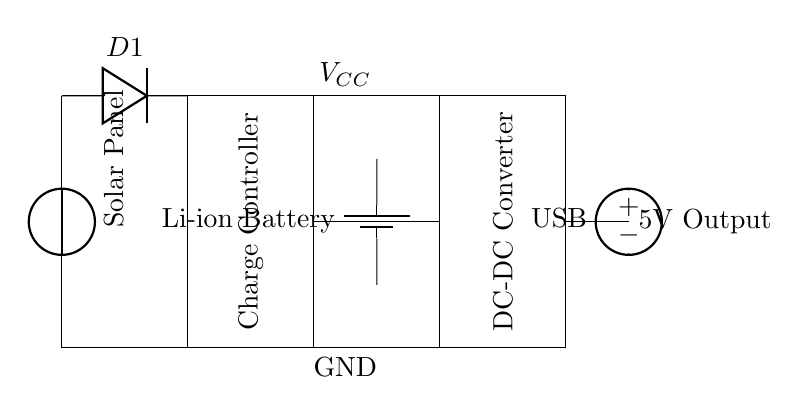What is the component labeled as D1? D1 is a diode, which allows current to flow in one direction only, protecting the circuit from reverse polarity from the solar panel.
Answer: Diode What is the purpose of the charge controller? The charge controller regulates the voltage and current coming from the solar panel to ensure proper charging of the battery, preventing overcharging.
Answer: Regulate charging How many outputs does the DC-DC converter provide? The circuit shows one output from the DC-DC converter, which is connected to the USB output.
Answer: One What is the voltage output at the USB? The USB output voltage is labeled as 5V, which is a standard voltage for USB devices, indicating the power available for charging.
Answer: 5V What type of battery is used in this circuit? The battery used in this circuit is a lithium-ion battery, which is commonly used due to its high energy density and efficiency.
Answer: Li-ion Battery What connection is made from the solar panel to the charge controller? The solar panel connects directly to the diode, and then to the input of the charge controller, ensuring the current is directed properly.
Answer: Diode to Charge Controller What role does the DC-DC converter play in the circuit? The DC-DC converter steps up or steps down the voltage, ensuring that the output to the USB is stable at the required 5V for charging portable devices.
Answer: Voltage adjustment 